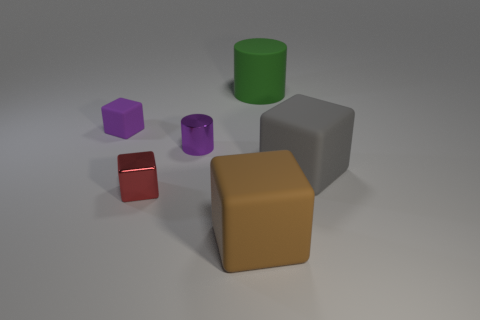Based on the arrangement of objects, what concepts might this image be used to illustrate? The arrangement of uniformly colored and simplistic geometric shapes may illustrate concepts of spatial relationships, object comparison, or mathematical principles such as volume and geometry. It could also serve as a visual aid in design or educational contexts to help viewers understand the principles of composition, balance, and proportion. 